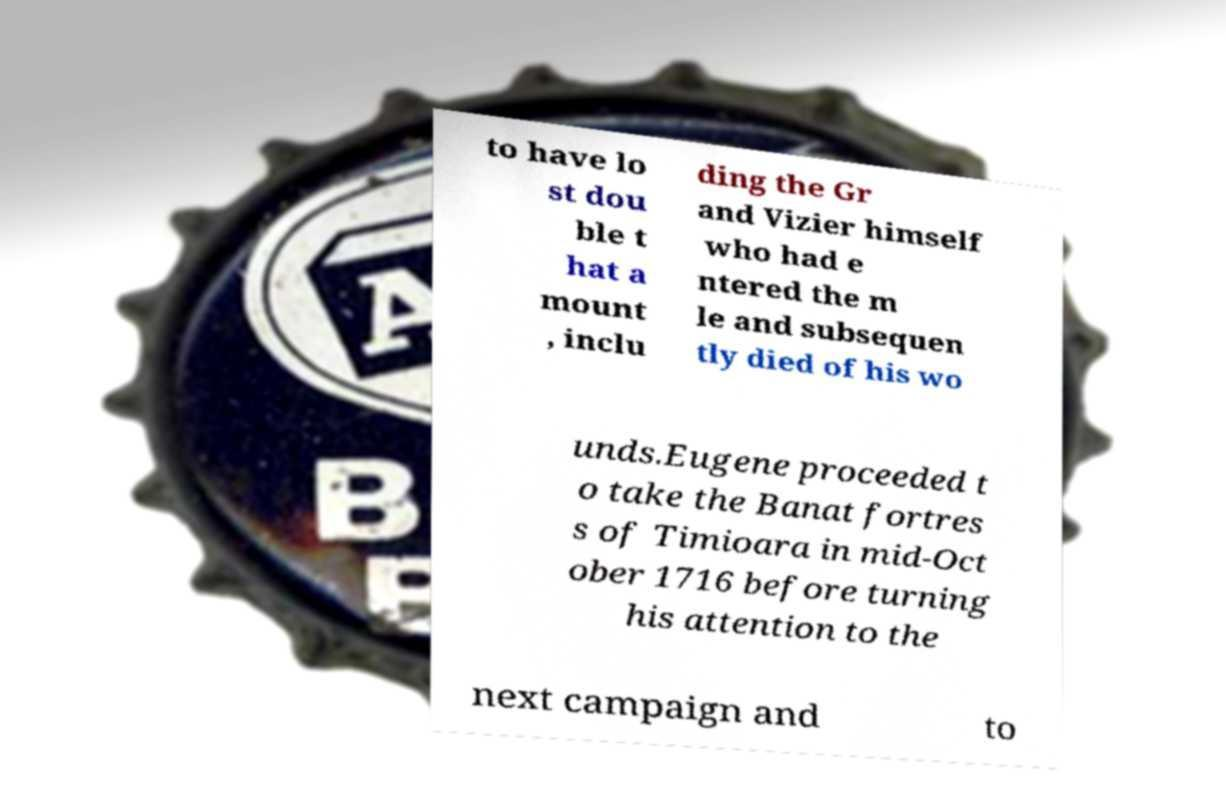There's text embedded in this image that I need extracted. Can you transcribe it verbatim? to have lo st dou ble t hat a mount , inclu ding the Gr and Vizier himself who had e ntered the m le and subsequen tly died of his wo unds.Eugene proceeded t o take the Banat fortres s of Timioara in mid-Oct ober 1716 before turning his attention to the next campaign and to 